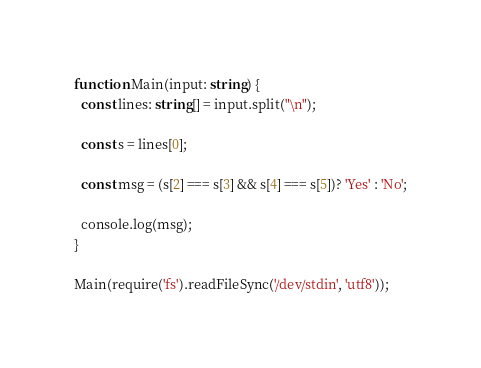Convert code to text. <code><loc_0><loc_0><loc_500><loc_500><_TypeScript_>function Main(input: string) {
  const lines: string[] = input.split("\n");

  const s = lines[0];
  
  const msg = (s[2] === s[3] && s[4] === s[5])? 'Yes' : 'No';
  
  console.log(msg);
}

Main(require('fs').readFileSync('/dev/stdin', 'utf8'));</code> 